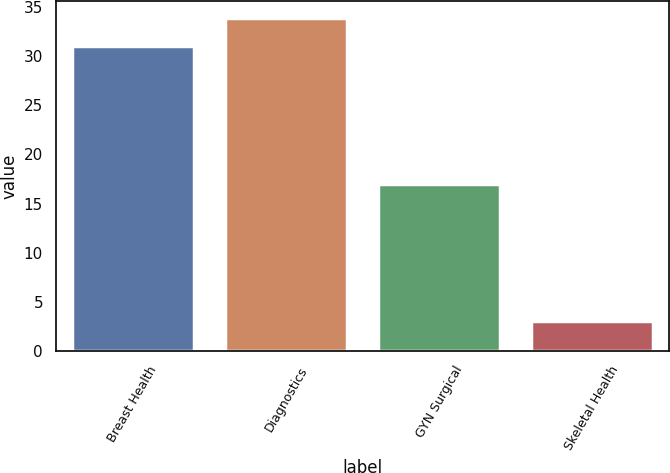Convert chart. <chart><loc_0><loc_0><loc_500><loc_500><bar_chart><fcel>Breast Health<fcel>Diagnostics<fcel>GYN Surgical<fcel>Skeletal Health<nl><fcel>31<fcel>33.9<fcel>17<fcel>3<nl></chart> 